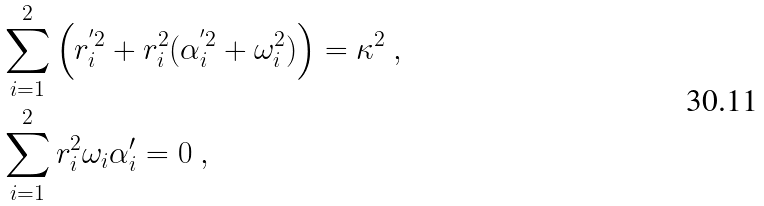<formula> <loc_0><loc_0><loc_500><loc_500>& \sum _ { i = 1 } ^ { 2 } \left ( r _ { i } ^ { ^ { \prime } 2 } + r _ { i } ^ { 2 } ( \alpha _ { i } ^ { ^ { \prime } 2 } + \omega _ { i } ^ { 2 } ) \right ) = \kappa ^ { 2 } \ , \\ & \sum _ { i = 1 } ^ { 2 } r _ { i } ^ { 2 } \omega _ { i } \alpha _ { i } ^ { \prime } = 0 \ ,</formula> 